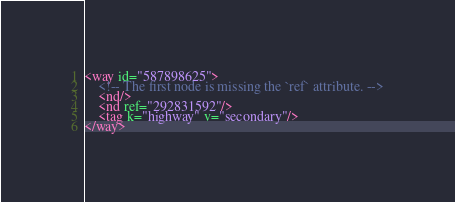Convert code to text. <code><loc_0><loc_0><loc_500><loc_500><_XML_><way id="587898625">
    <!-- The first node is missing the `ref` attribute. -->
    <nd/>
    <nd ref="292831592"/>
    <tag k="highway" v="secondary"/>
</way>
</code> 